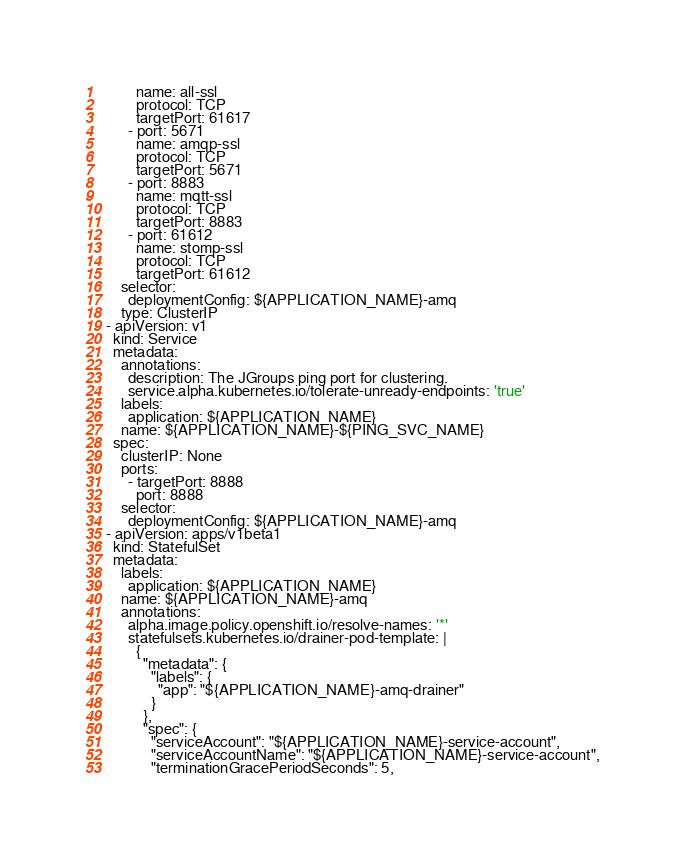<code> <loc_0><loc_0><loc_500><loc_500><_YAML_>          name: all-ssl
          protocol: TCP
          targetPort: 61617
        - port: 5671
          name: amqp-ssl
          protocol: TCP
          targetPort: 5671
        - port: 8883
          name: mqtt-ssl
          protocol: TCP
          targetPort: 8883
        - port: 61612
          name: stomp-ssl
          protocol: TCP
          targetPort: 61612
      selector:
        deploymentConfig: ${APPLICATION_NAME}-amq
      type: ClusterIP
  - apiVersion: v1
    kind: Service
    metadata:
      annotations:
        description: The JGroups ping port for clustering.
        service.alpha.kubernetes.io/tolerate-unready-endpoints: 'true'
      labels:
        application: ${APPLICATION_NAME}
      name: ${APPLICATION_NAME}-${PING_SVC_NAME}
    spec:
      clusterIP: None
      ports:
        - targetPort: 8888
          port: 8888
      selector:
        deploymentConfig: ${APPLICATION_NAME}-amq
  - apiVersion: apps/v1beta1
    kind: StatefulSet
    metadata:
      labels:
        application: ${APPLICATION_NAME}
      name: ${APPLICATION_NAME}-amq
      annotations:
        alpha.image.policy.openshift.io/resolve-names: '*'
        statefulsets.kubernetes.io/drainer-pod-template: |
          {
            "metadata": {
              "labels": {
                "app": "${APPLICATION_NAME}-amq-drainer"
              }
            },
            "spec": {
              "serviceAccount": "${APPLICATION_NAME}-service-account",
              "serviceAccountName": "${APPLICATION_NAME}-service-account",
              "terminationGracePeriodSeconds": 5,</code> 